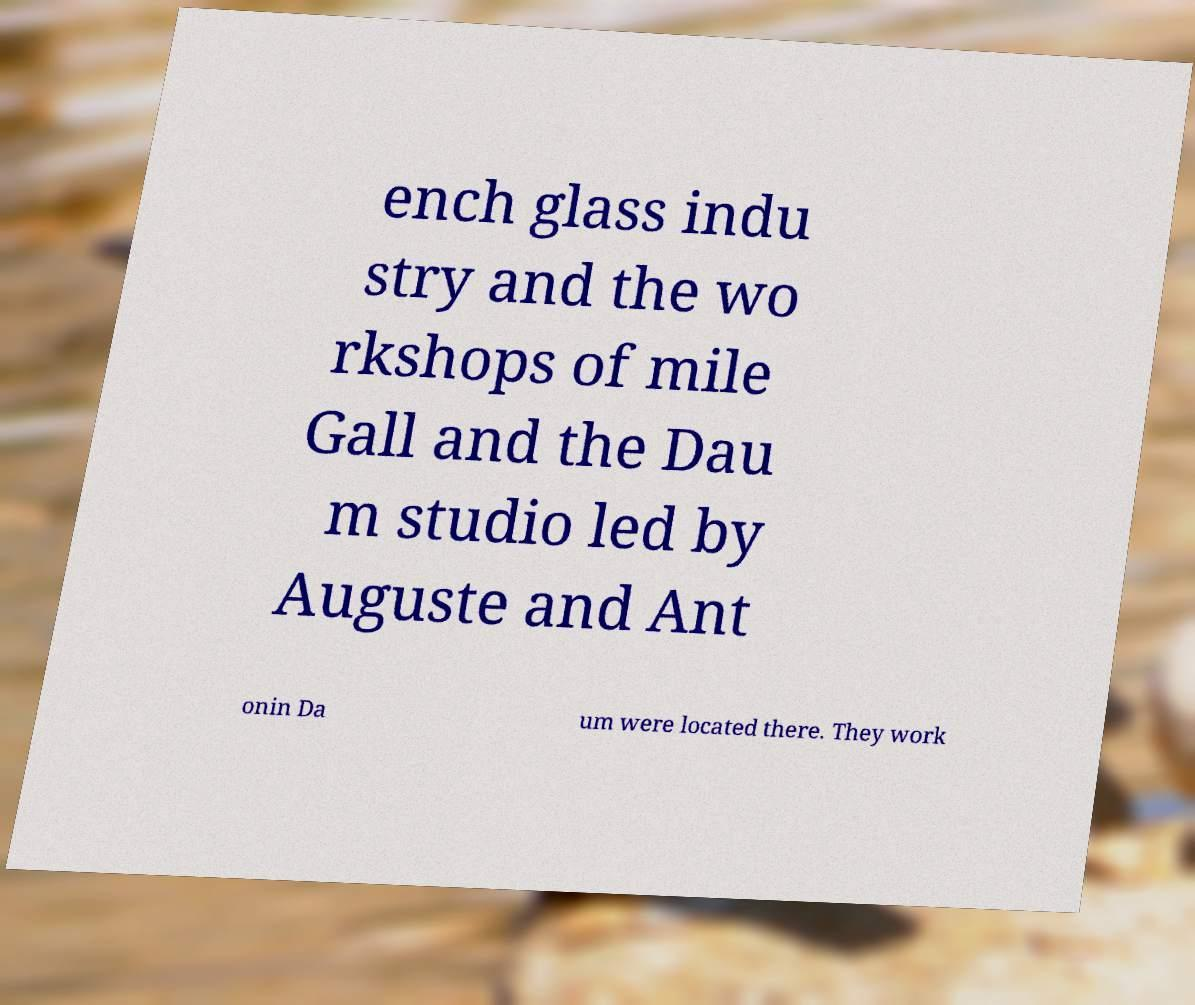Can you read and provide the text displayed in the image?This photo seems to have some interesting text. Can you extract and type it out for me? ench glass indu stry and the wo rkshops of mile Gall and the Dau m studio led by Auguste and Ant onin Da um were located there. They work 